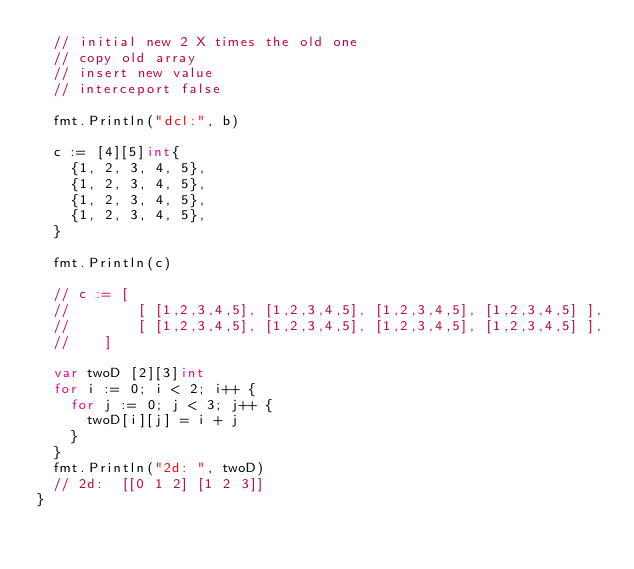Convert code to text. <code><loc_0><loc_0><loc_500><loc_500><_Go_>	// initial new 2 X times the old one
	// copy old array
	// insert new value
	// interceport false

	fmt.Println("dcl:", b)

	c := [4][5]int{
		{1, 2, 3, 4, 5},
		{1, 2, 3, 4, 5},
		{1, 2, 3, 4, 5},
		{1, 2, 3, 4, 5},
	}

	fmt.Println(c)

	// c := [
	// 				[ [1,2,3,4,5], [1,2,3,4,5], [1,2,3,4,5], [1,2,3,4,5] ],
	// 				[ [1,2,3,4,5], [1,2,3,4,5], [1,2,3,4,5], [1,2,3,4,5] ],
	//    ]

	var twoD [2][3]int
	for i := 0; i < 2; i++ {
		for j := 0; j < 3; j++ {
			twoD[i][j] = i + j
		}
	}
	fmt.Println("2d: ", twoD)
	// 2d:  [[0 1 2] [1 2 3]]
}
</code> 